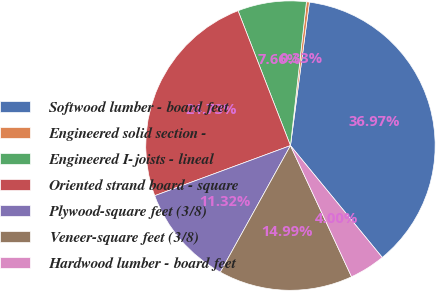<chart> <loc_0><loc_0><loc_500><loc_500><pie_chart><fcel>Softwood lumber - board feet<fcel>Engineered solid section -<fcel>Engineered I-joists - lineal<fcel>Oriented strand board - square<fcel>Plywood-square feet (3/8)<fcel>Veneer-square feet (3/8)<fcel>Hardwood lumber - board feet<nl><fcel>36.97%<fcel>0.33%<fcel>7.66%<fcel>24.73%<fcel>11.32%<fcel>14.99%<fcel>4.0%<nl></chart> 